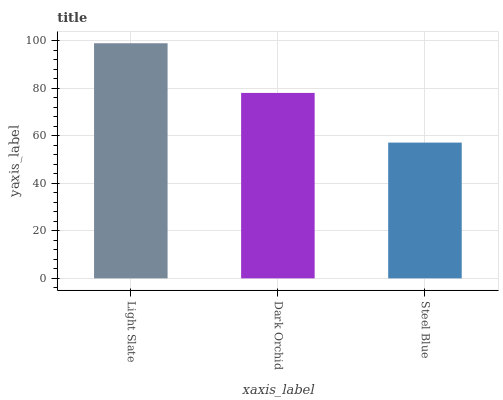Is Steel Blue the minimum?
Answer yes or no. Yes. Is Light Slate the maximum?
Answer yes or no. Yes. Is Dark Orchid the minimum?
Answer yes or no. No. Is Dark Orchid the maximum?
Answer yes or no. No. Is Light Slate greater than Dark Orchid?
Answer yes or no. Yes. Is Dark Orchid less than Light Slate?
Answer yes or no. Yes. Is Dark Orchid greater than Light Slate?
Answer yes or no. No. Is Light Slate less than Dark Orchid?
Answer yes or no. No. Is Dark Orchid the high median?
Answer yes or no. Yes. Is Dark Orchid the low median?
Answer yes or no. Yes. Is Steel Blue the high median?
Answer yes or no. No. Is Steel Blue the low median?
Answer yes or no. No. 